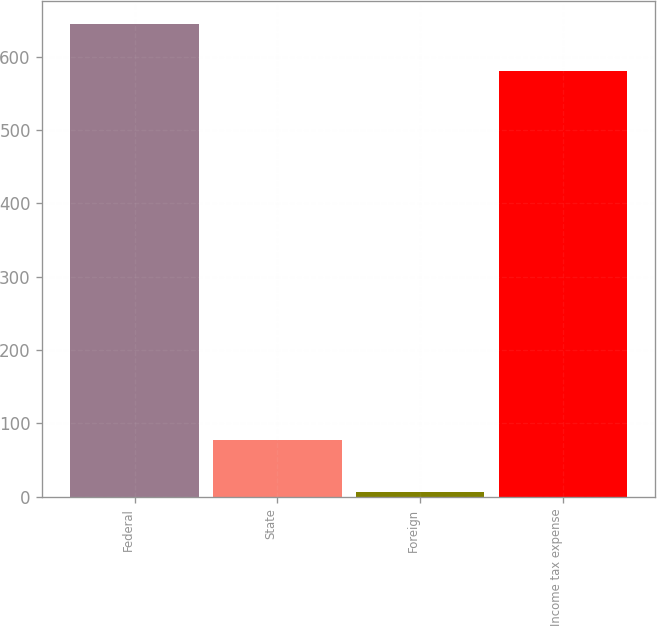Convert chart to OTSL. <chart><loc_0><loc_0><loc_500><loc_500><bar_chart><fcel>Federal<fcel>State<fcel>Foreign<fcel>Income tax expense<nl><fcel>644.4<fcel>78<fcel>6<fcel>581<nl></chart> 